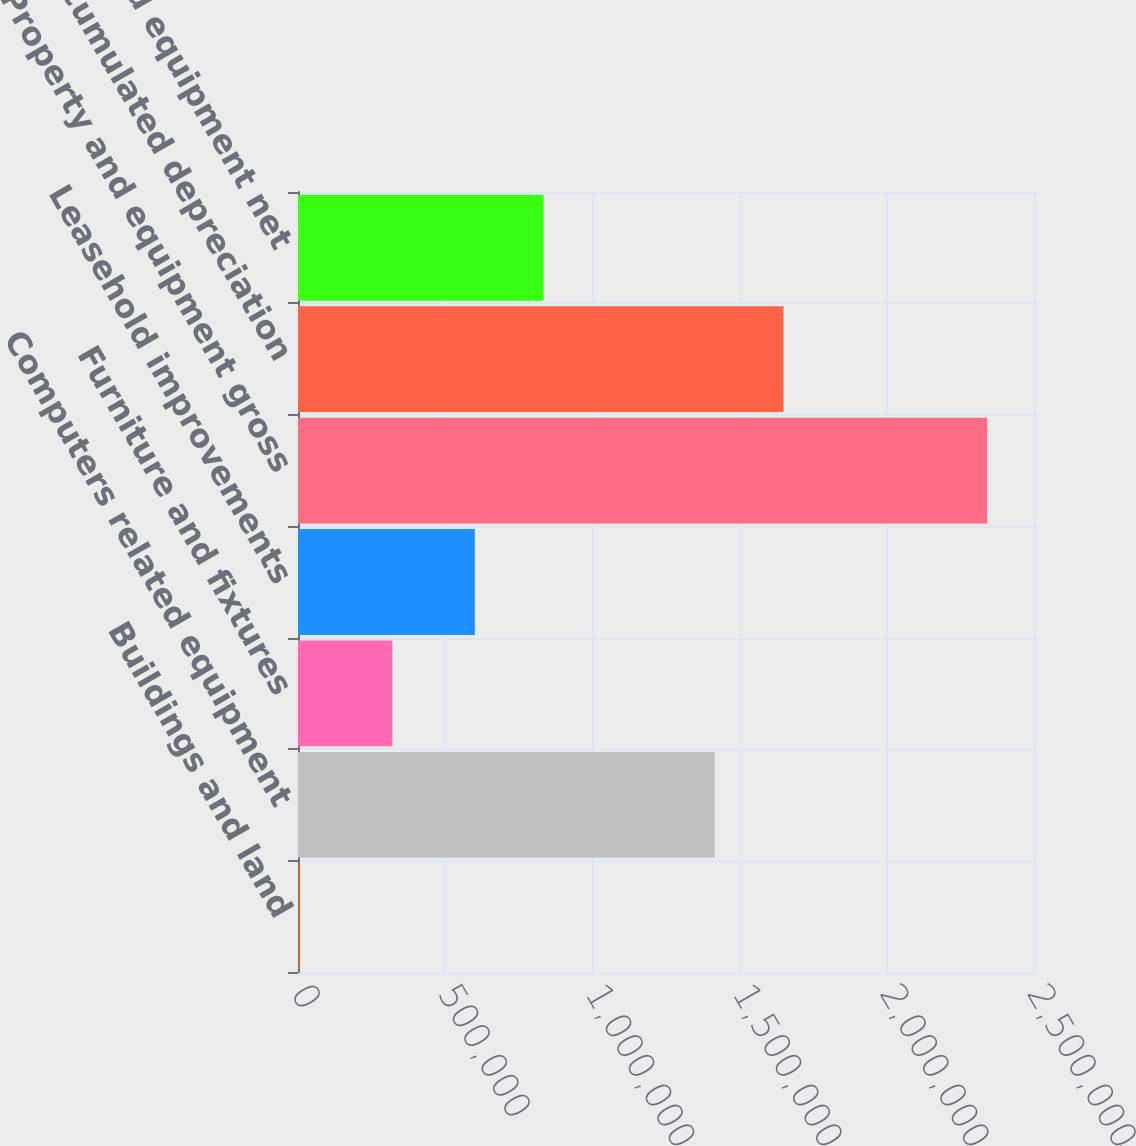<chart> <loc_0><loc_0><loc_500><loc_500><bar_chart><fcel>Buildings and land<fcel>Computers related equipment<fcel>Furniture and fixtures<fcel>Leasehold improvements<fcel>Property and equipment gross<fcel>Total accumulated depreciation<fcel>Property and equipment net<nl><fcel>4286<fcel>1.41544e+06<fcel>320589<fcel>600701<fcel>2.34102e+06<fcel>1.64911e+06<fcel>834374<nl></chart> 